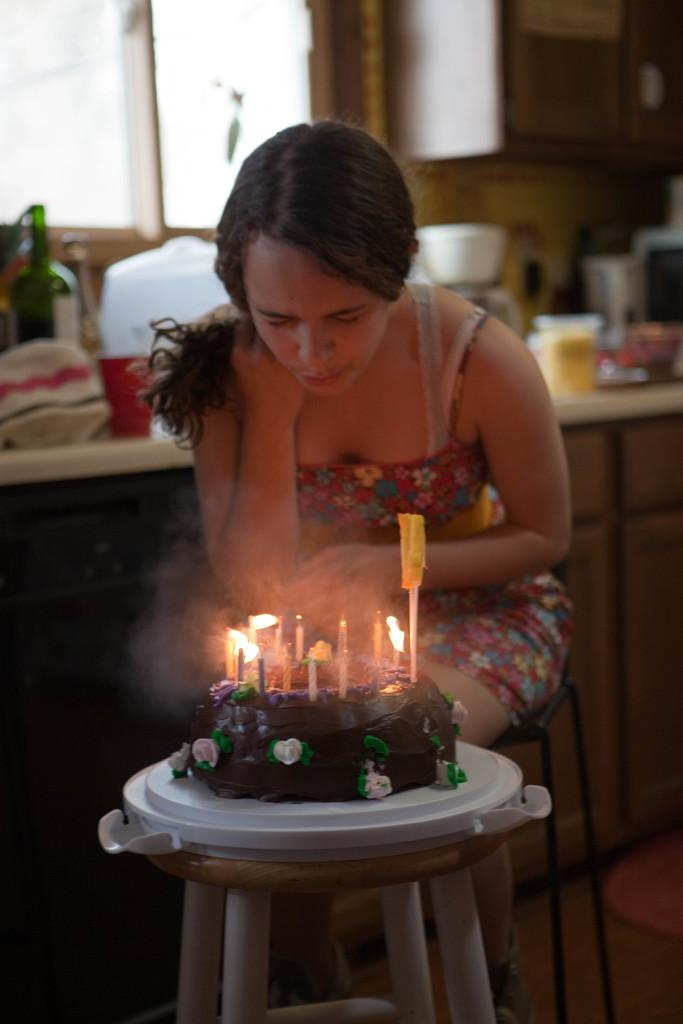Who is the main subject in the image? There is a woman in the image. What is the woman doing in the image? The woman is sitting in front of a stool. What is on the stool that the woman is sitting in front of? There is a cake on the stool. What is on top of the cake? There are candles on the cake. What type of stocking is the woman wearing in the image? There is no information about the woman's stockings in the image, so we cannot determine if she is wearing any. 